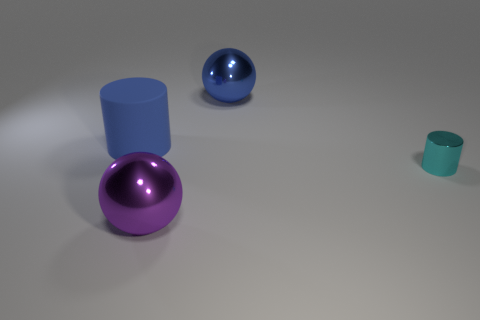Do the purple ball and the sphere behind the tiny cyan shiny cylinder have the same material?
Give a very brief answer. Yes. Is there a large red cylinder?
Keep it short and to the point. No. There is a blue object that is on the left side of the big metallic thing behind the rubber cylinder; is there a big thing that is on the right side of it?
Your answer should be very brief. Yes. What number of tiny things are metallic objects or brown rubber things?
Offer a terse response. 1. The metallic object that is the same size as the blue sphere is what color?
Your response must be concise. Purple. There is a blue matte cylinder; how many metal things are in front of it?
Give a very brief answer. 2. Is there a purple thing made of the same material as the large blue sphere?
Your response must be concise. Yes. The big shiny object that is the same color as the large cylinder is what shape?
Your answer should be very brief. Sphere. There is a large ball that is in front of the rubber cylinder; what is its color?
Your response must be concise. Purple. Are there an equal number of metal balls right of the blue rubber object and large purple metallic balls to the left of the cyan metallic cylinder?
Make the answer very short. No. 